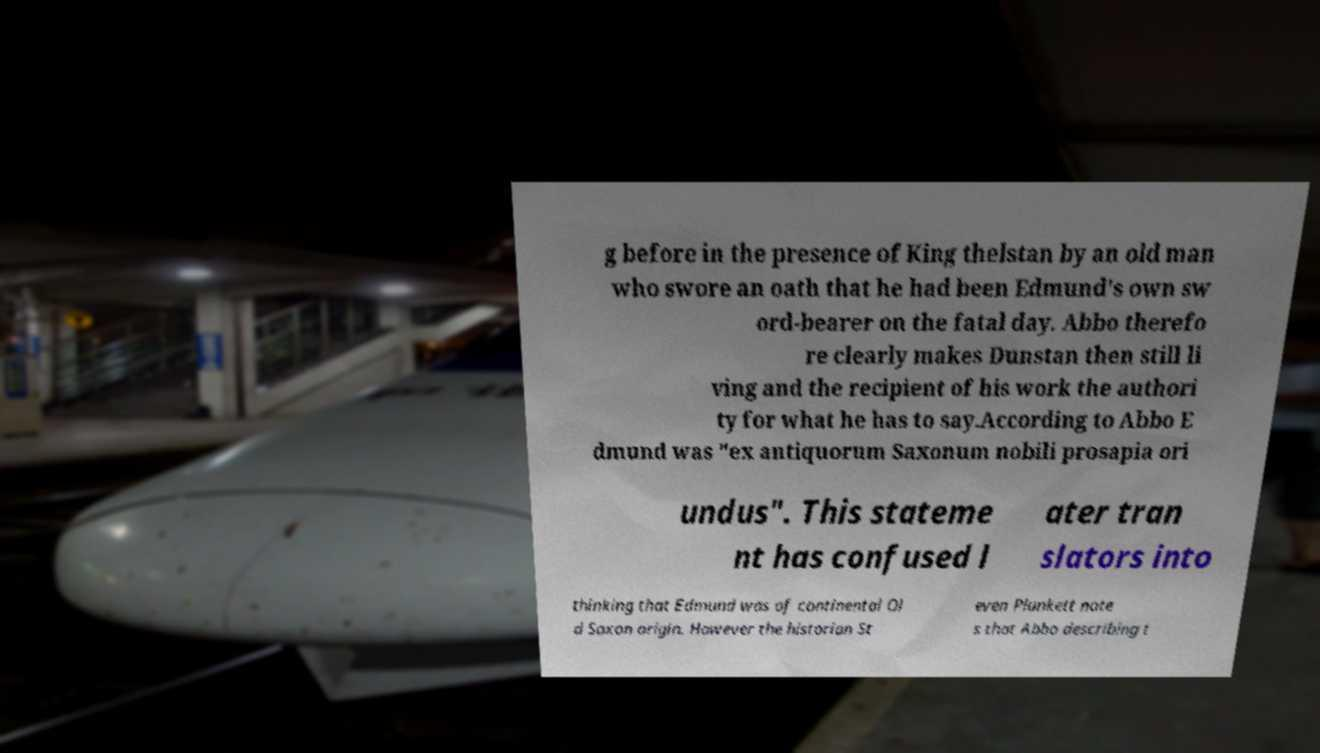Can you accurately transcribe the text from the provided image for me? g before in the presence of King thelstan by an old man who swore an oath that he had been Edmund's own sw ord-bearer on the fatal day. Abbo therefo re clearly makes Dunstan then still li ving and the recipient of his work the authori ty for what he has to say.According to Abbo E dmund was "ex antiquorum Saxonum nobili prosapia ori undus". This stateme nt has confused l ater tran slators into thinking that Edmund was of continental Ol d Saxon origin. However the historian St even Plunkett note s that Abbo describing t 